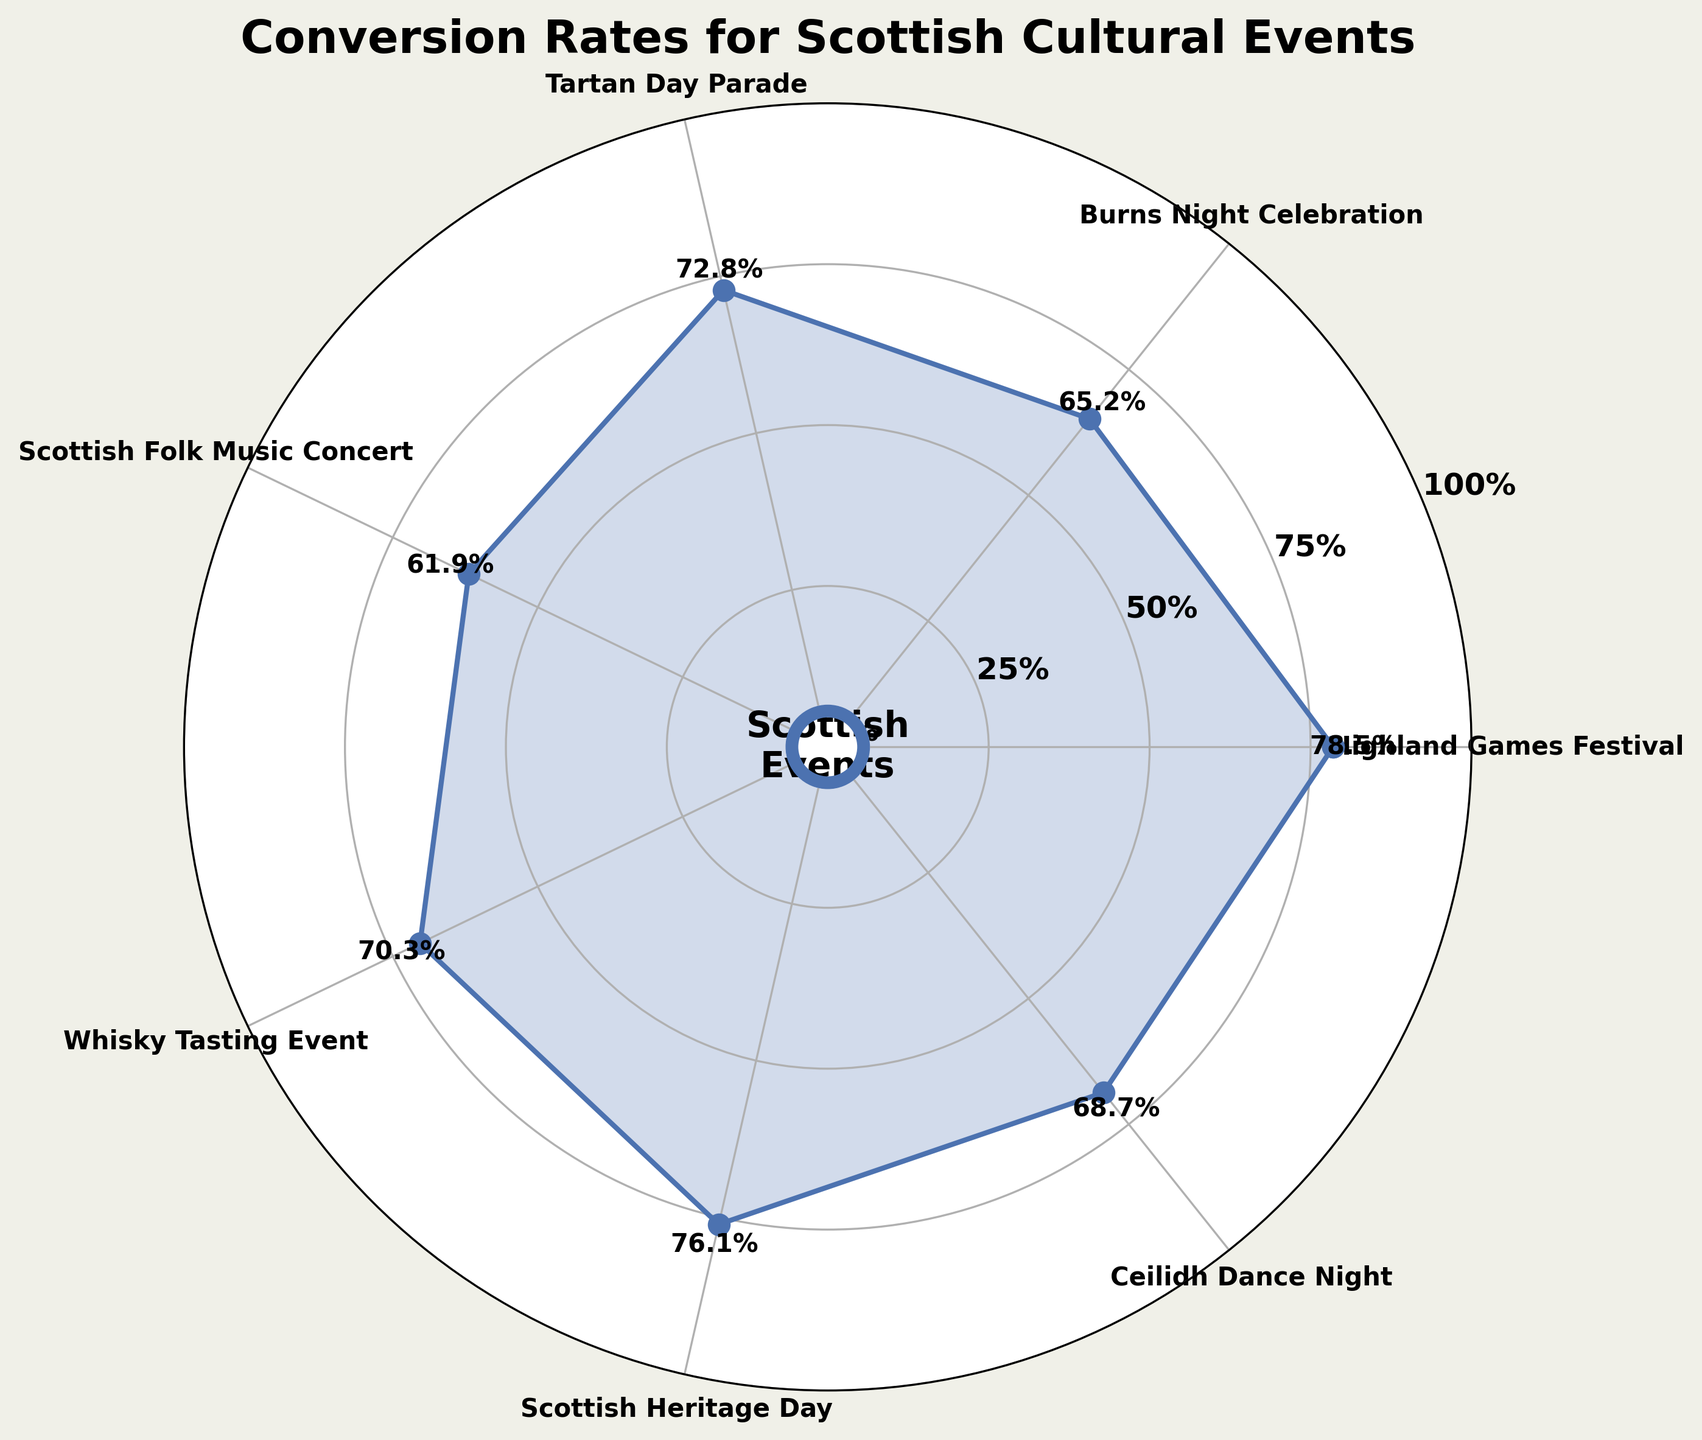What is the title of the plot? The title of the plot is displayed at the top.
Answer: Conversion Rates for Scottish Cultural Events Which event has the highest conversion rate? From the visual on the plot, the event with the highest data point is recognized.
Answer: Highland Games Festival What is the conversion rate for the Whisky Tasting Event? The rate is written by the data point corresponding to the Whisky Tasting Event.
Answer: 70.3% How many events are shown in the plot? Count the number of unique data points or labels.
Answer: 7 Which event has the lowest conversion rate? Identify the event with the lowest data point on the radial chart.
Answer: Scottish Folk Music Concert What is the average conversion rate across all events? Sum each conversion rate and divide by the number of events (78.5 + 65.2 + 72.8 + 61.9 + 70.3 + 76.1 + 68.7) / 7.
Answer: 70.5% Which event has a conversion rate close to the average conversion rate? Compare individual conversion rates to the average calculated (70.5%) and find the closest event.
Answer: Whisky Tasting Event What is the comparison between the Tartan Day Parade and Burns Night Celebration in terms of conversion rates? Subtract the conversion rate of Burns Night Celebration from the Tartan Day Parade (72.8 - 65.2).
Answer: 7.6% higher How does the conversion rate of the Ceilidh Dance Night compare to the Scottish Heritage Day? Compare the conversion rates of Ceilidh Dance Night (68.7%) and Scottish Heritage Day (76.1%).
Answer: 7.4% lower Are the conversion rates for the events relatively uniform or varied? Assess the consistency among the data points. Since the rates range from 61.9% to 78.5%, the rates are varied but not highly dispersed.
Answer: Varied 